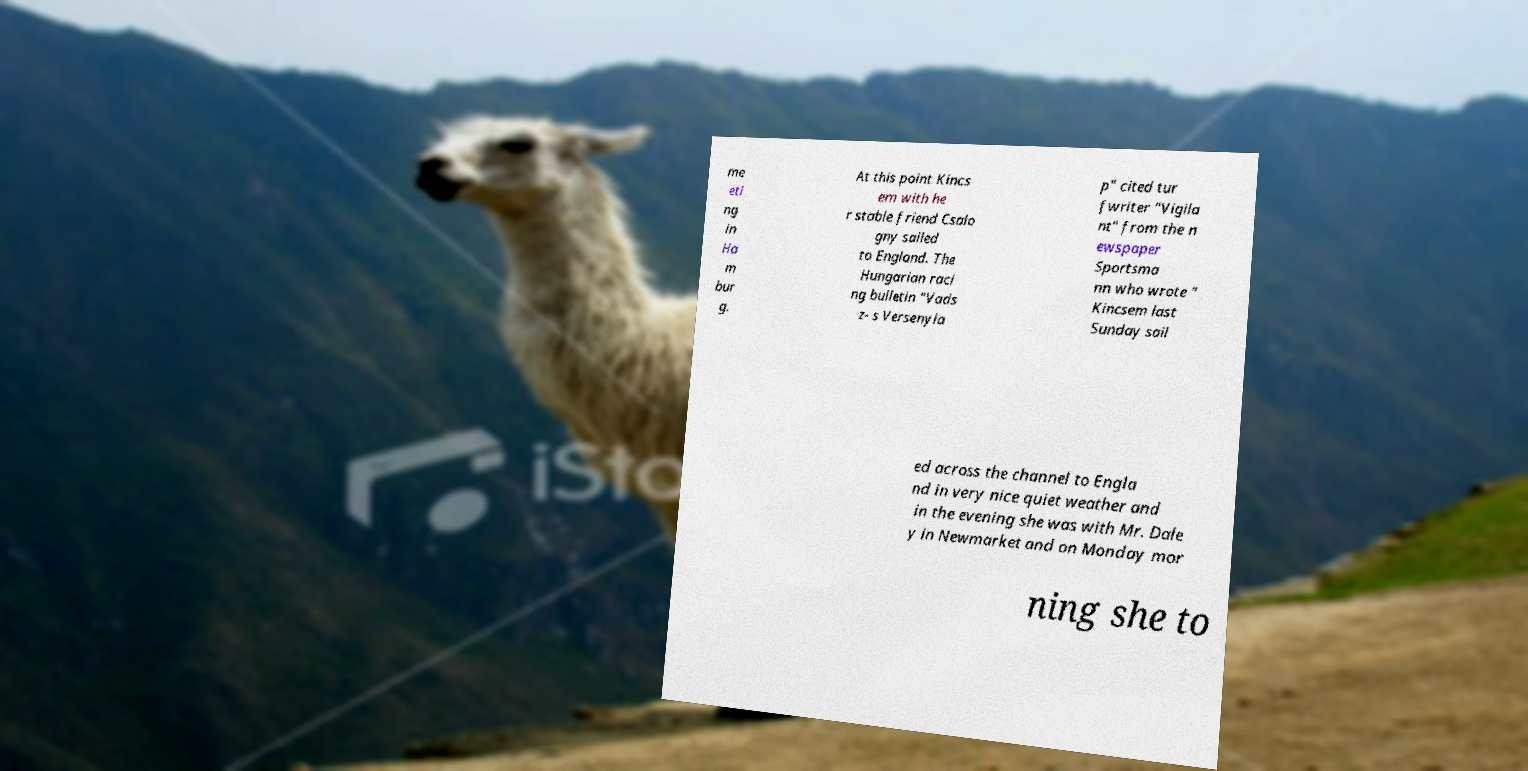Please identify and transcribe the text found in this image. me eti ng in Ha m bur g. At this point Kincs em with he r stable friend Csalo gny sailed to England. The Hungarian raci ng bulletin "Vads z- s Versenyla p" cited tur fwriter "Vigila nt" from the n ewspaper Sportsma nn who wrote " Kincsem last Sunday sail ed across the channel to Engla nd in very nice quiet weather and in the evening she was with Mr. Dale y in Newmarket and on Monday mor ning she to 